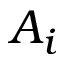Convert formula to latex. <formula><loc_0><loc_0><loc_500><loc_500>A _ { i }</formula> 